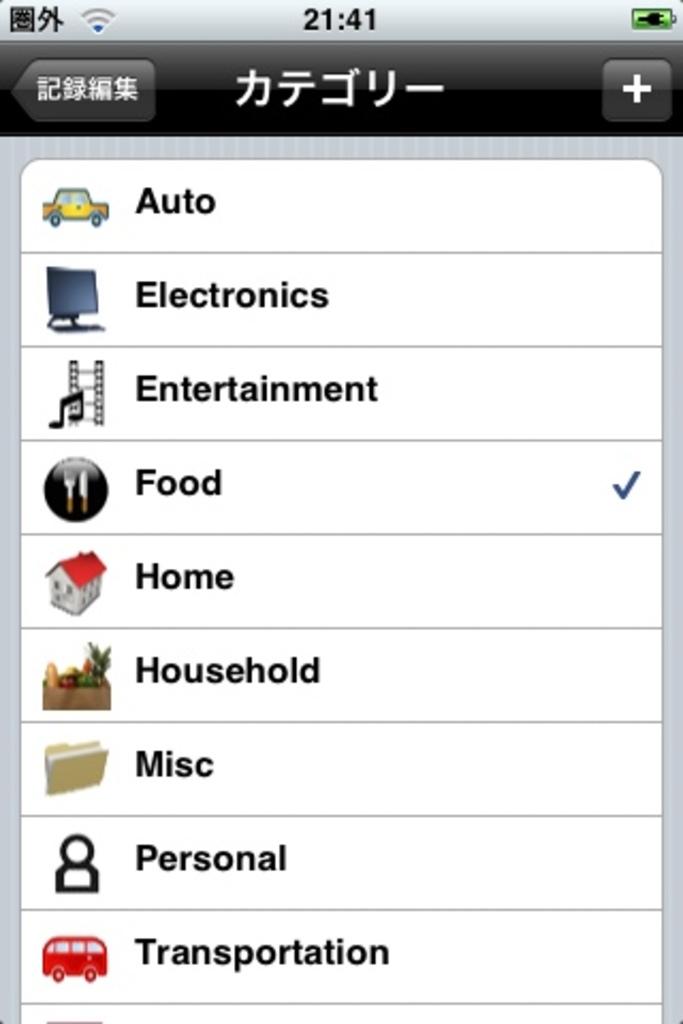What time is displayed on this screenshot?
Your answer should be very brief. 21:41. What category is checked?
Your answer should be very brief. Food. 